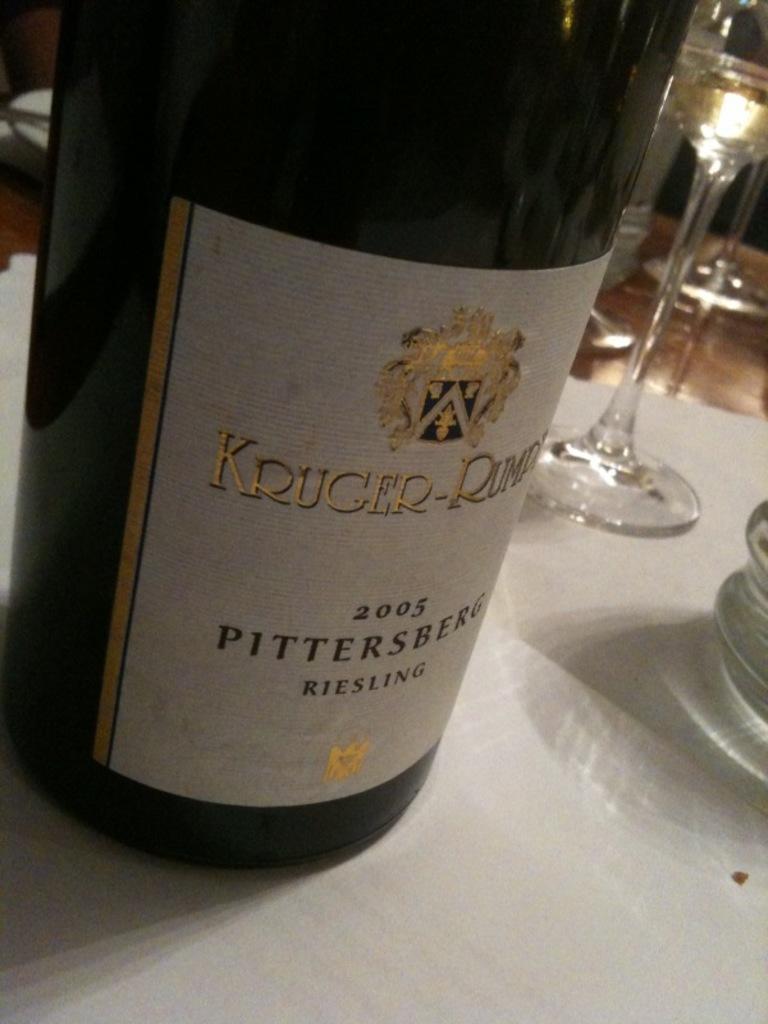Describe this image in one or two sentences. Here we can see a bottle, and glasses on the platform. 